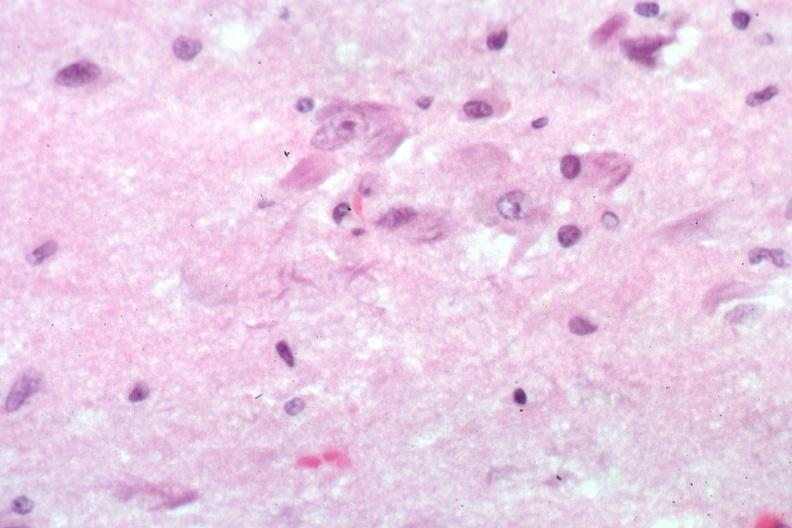what is present?
Answer the question using a single word or phrase. Senile plaque 